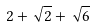<formula> <loc_0><loc_0><loc_500><loc_500>2 + \sqrt { 2 } + \sqrt { 6 }</formula> 